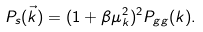<formula> <loc_0><loc_0><loc_500><loc_500>P _ { s } ( \vec { k } ) = ( 1 + \beta \mu _ { k } ^ { 2 } ) ^ { 2 } P _ { g g } ( k ) .</formula> 